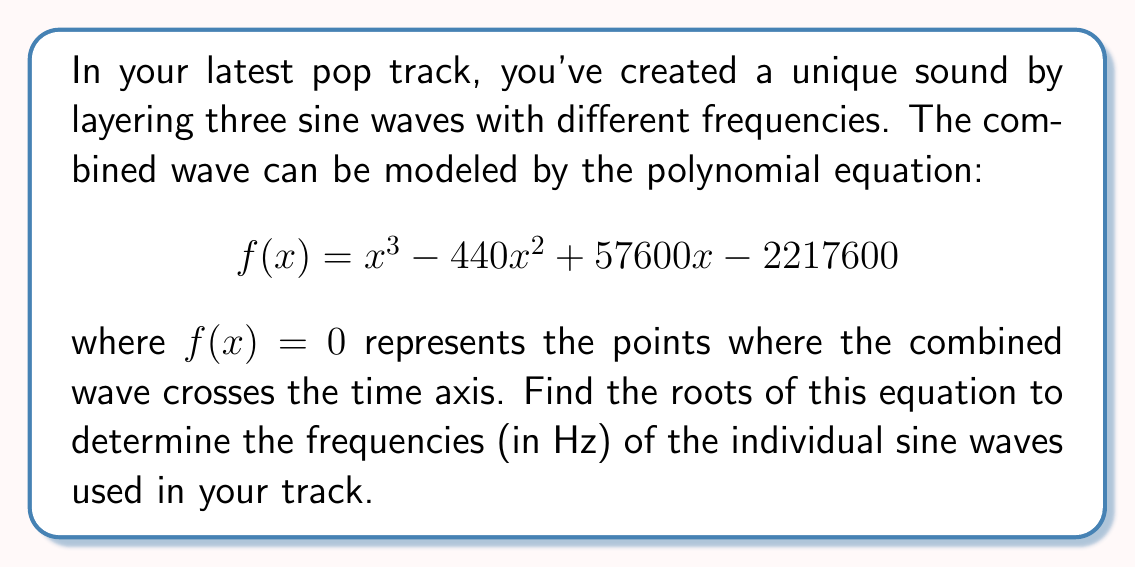Teach me how to tackle this problem. To find the roots of the polynomial equation, we'll use the following steps:

1) First, we can try to factor out any common factors. In this case, there are no common factors.

2) Next, we can check if any rational roots exist using the rational root theorem. The possible rational roots are the factors of the constant term: $\pm 1, \pm 2, \pm 3, \pm 4, \pm 6, \pm 8, \pm 11, \pm 12, \pm 16, \pm 22, \pm 24, \pm 33, \pm 44, \pm 48, \pm 66, \pm 88, \pm 96, \pm 132, \pm 176, \pm 264, \pm 552, \pm 1108, \pm 2216600$.

3) Testing these values, we find that 110 is a root of the equation.

4) We can factor out $(x - 110)$ from the original polynomial:

   $$f(x) = (x - 110)(x^2 - 330x + 20160)$$

5) Now we need to solve the quadratic equation $x^2 - 330x + 20160 = 0$.

6) We can use the quadratic formula: $x = \frac{-b \pm \sqrt{b^2 - 4ac}}{2a}$

   Where $a = 1$, $b = -330$, and $c = 20160$

7) Substituting these values:

   $$x = \frac{330 \pm \sqrt{330^2 - 4(1)(20160)}}{2(1)}$$
   $$x = \frac{330 \pm \sqrt{108900 - 80640}}{2}$$
   $$x = \frac{330 \pm \sqrt{28260}}{2}$$
   $$x = \frac{330 \pm 168.11}{2}$$

8) This gives us two more roots:

   $$x = \frac{330 + 168.11}{2} \approx 249.055$$
   $$x = \frac{330 - 168.11}{2} \approx 80.945$$

Therefore, the three roots of the equation are 110 Hz, 249.055 Hz, and 80.945 Hz.
Answer: The roots of the polynomial equation are approximately 110 Hz, 249.055 Hz, and 80.945 Hz. 